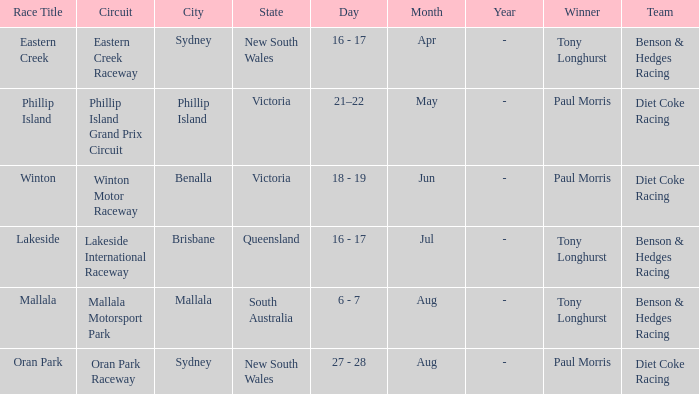What was the name of the driver that won the Lakeside race? Tony Longhurst. 